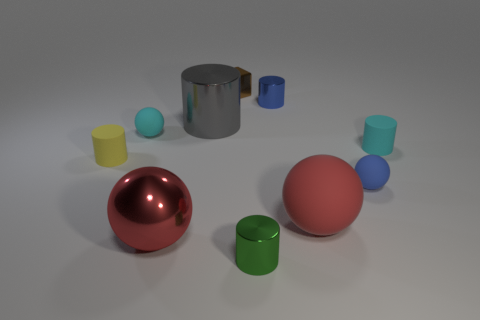How many cylinders are the same color as the cube?
Ensure brevity in your answer.  0. There is another large object that is the same color as the large matte object; what is its material?
Your response must be concise. Metal. What number of shiny objects are both to the right of the large red shiny thing and in front of the blue matte thing?
Make the answer very short. 1. There is a cylinder that is to the right of the metal object that is right of the tiny green metal cylinder; what is it made of?
Make the answer very short. Rubber. Are there any large green things made of the same material as the small blue sphere?
Offer a terse response. No. There is a gray object that is the same size as the red matte ball; what is it made of?
Ensure brevity in your answer.  Metal. There is a rubber object behind the small rubber cylinder that is behind the rubber cylinder to the left of the red metallic thing; what size is it?
Your answer should be very brief. Small. Are there any tiny things that are in front of the small rubber object that is on the left side of the cyan matte ball?
Keep it short and to the point. Yes. There is a brown shiny object; does it have the same shape as the blue object that is right of the big red rubber thing?
Your answer should be very brief. No. The tiny metallic cylinder that is in front of the yellow rubber object is what color?
Provide a short and direct response. Green. 